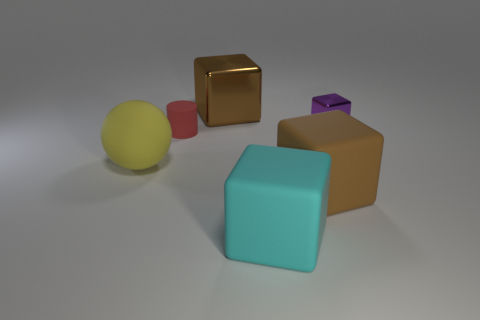Is the shape of the big brown thing in front of the big rubber sphere the same as  the big cyan matte object?
Keep it short and to the point. Yes. Is there a tiny gray cube?
Ensure brevity in your answer.  No. The large thing that is behind the tiny matte cylinder on the left side of the big cube to the left of the large cyan thing is what color?
Your answer should be compact. Brown. Are there the same number of large brown shiny cubes that are right of the purple thing and large objects to the left of the cyan rubber object?
Make the answer very short. No. The purple thing that is the same size as the red rubber thing is what shape?
Give a very brief answer. Cube. Is there another object of the same color as the large shiny object?
Provide a succinct answer. Yes. What is the shape of the small thing that is left of the cyan thing?
Offer a terse response. Cylinder. What is the color of the matte cylinder?
Provide a short and direct response. Red. What color is the cylinder that is made of the same material as the ball?
Give a very brief answer. Red. How many other big blocks are the same material as the purple block?
Give a very brief answer. 1. 